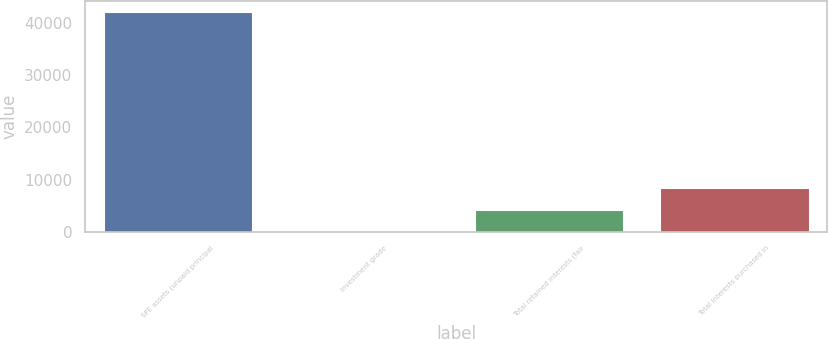Convert chart. <chart><loc_0><loc_0><loc_500><loc_500><bar_chart><fcel>SPE assets (unpaid principal<fcel>Investment grade<fcel>Total retained interests (fair<fcel>Total interests purchased in<nl><fcel>41977<fcel>14<fcel>4210.3<fcel>8406.6<nl></chart> 